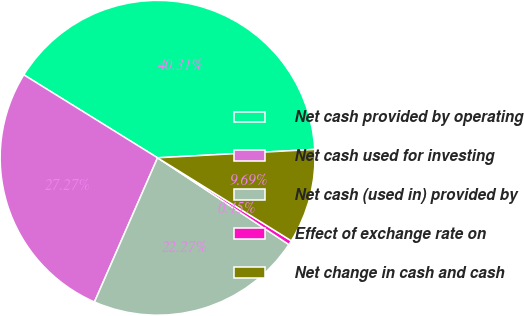Convert chart to OTSL. <chart><loc_0><loc_0><loc_500><loc_500><pie_chart><fcel>Net cash provided by operating<fcel>Net cash used for investing<fcel>Net cash (used in) provided by<fcel>Effect of exchange rate on<fcel>Net change in cash and cash<nl><fcel>40.31%<fcel>27.27%<fcel>22.27%<fcel>0.45%<fcel>9.69%<nl></chart> 